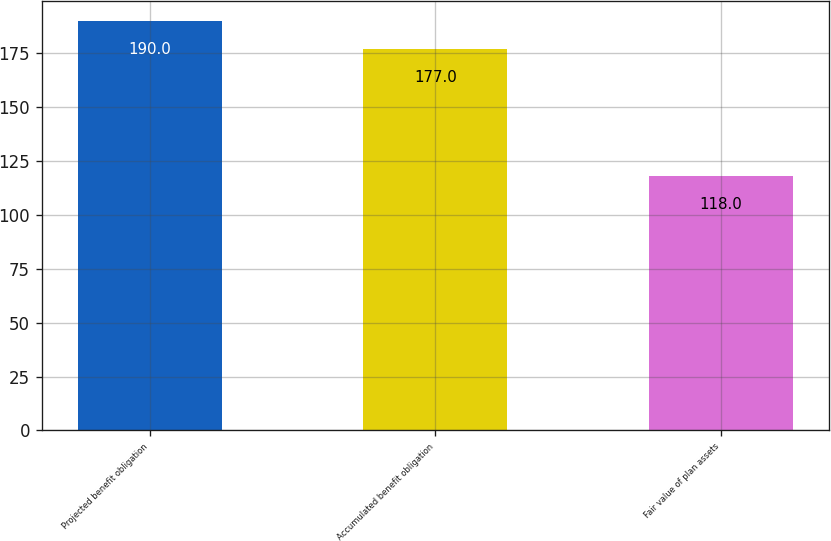Convert chart. <chart><loc_0><loc_0><loc_500><loc_500><bar_chart><fcel>Projected benefit obligation<fcel>Accumulated benefit obligation<fcel>Fair value of plan assets<nl><fcel>190<fcel>177<fcel>118<nl></chart> 